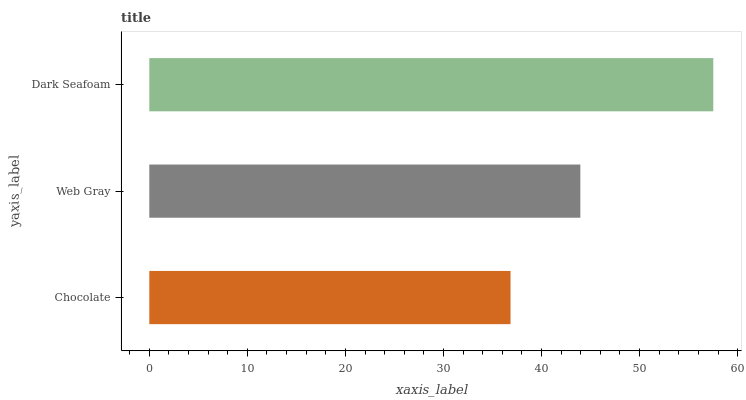Is Chocolate the minimum?
Answer yes or no. Yes. Is Dark Seafoam the maximum?
Answer yes or no. Yes. Is Web Gray the minimum?
Answer yes or no. No. Is Web Gray the maximum?
Answer yes or no. No. Is Web Gray greater than Chocolate?
Answer yes or no. Yes. Is Chocolate less than Web Gray?
Answer yes or no. Yes. Is Chocolate greater than Web Gray?
Answer yes or no. No. Is Web Gray less than Chocolate?
Answer yes or no. No. Is Web Gray the high median?
Answer yes or no. Yes. Is Web Gray the low median?
Answer yes or no. Yes. Is Dark Seafoam the high median?
Answer yes or no. No. Is Chocolate the low median?
Answer yes or no. No. 